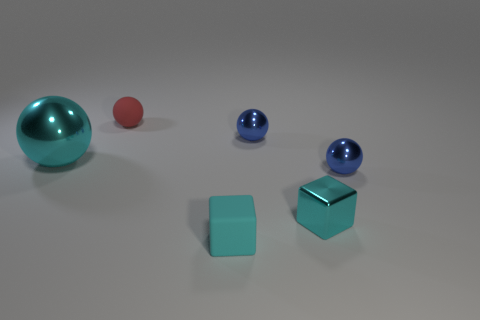Is there anything else that is the same size as the cyan metal sphere?
Your answer should be compact. No. There is a red matte object; what number of rubber things are in front of it?
Your response must be concise. 1. Do the matte object that is behind the cyan matte cube and the cyan matte object have the same size?
Your response must be concise. Yes. There is a metal object that is the same shape as the cyan rubber thing; what color is it?
Make the answer very short. Cyan. Is there any other thing that is the same shape as the small red thing?
Keep it short and to the point. Yes. There is a small cyan object that is behind the cyan matte block; what shape is it?
Make the answer very short. Cube. How many small shiny objects are the same shape as the large object?
Keep it short and to the point. 2. There is a matte thing that is in front of the large cyan ball; does it have the same color as the cube that is behind the tiny matte cube?
Your response must be concise. Yes. How many objects are either large brown metallic cylinders or cubes?
Offer a terse response. 2. How many other big spheres are made of the same material as the red sphere?
Make the answer very short. 0. 